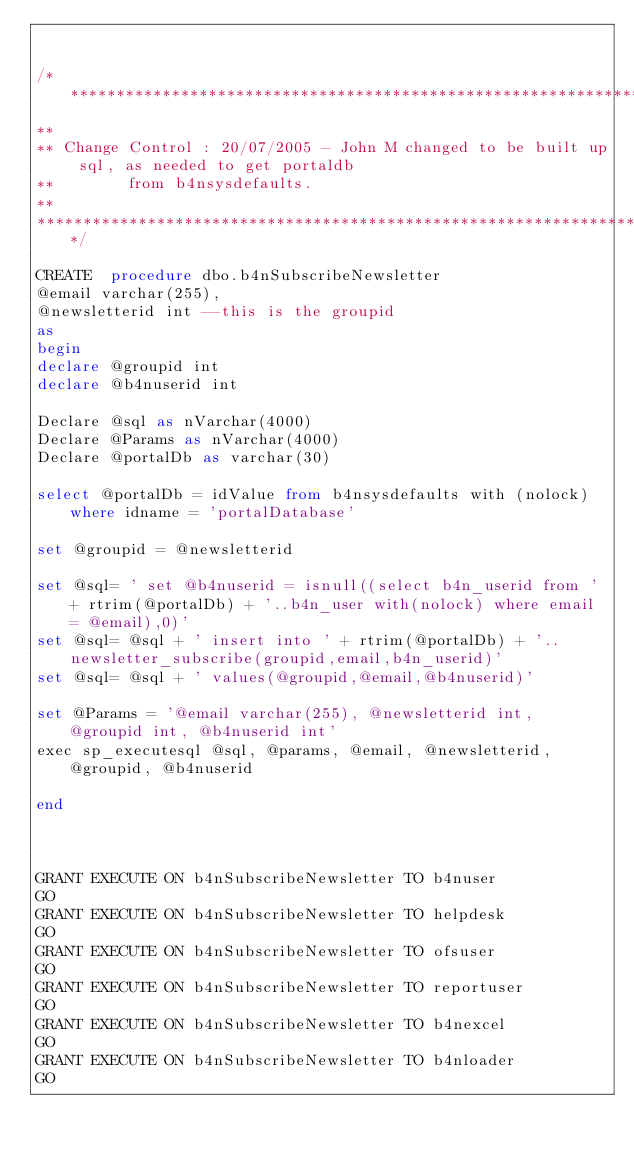<code> <loc_0><loc_0><loc_500><loc_500><_SQL_>

/**********************************************************************************************************************
**									
** Change Control	:	20/07/2005 - John M changed to be built up sql, as needed to get portaldb 
**				from b4nsysdefaults.
**
**********************************************************************************************************************/

CREATE  procedure dbo.b4nSubscribeNewsletter
@email varchar(255),
@newsletterid int --this is the groupid
as
begin
declare @groupid int
declare @b4nuserid int

Declare @sql as nVarchar(4000)
Declare @Params as nVarchar(4000)
Declare @portalDb as varchar(30)

select @portalDb = idValue from b4nsysdefaults with (nolock) where idname = 'portalDatabase'

set @groupid = @newsletterid

set @sql= ' set @b4nuserid = isnull((select b4n_userid from ' + rtrim(@portalDb) + '..b4n_user with(nolock) where email = @email),0)'
set @sql= @sql + ' insert into ' + rtrim(@portalDb) + '..newsletter_subscribe(groupid,email,b4n_userid)'
set @sql= @sql + ' values(@groupid,@email,@b4nuserid)'

set @Params = '@email varchar(255), @newsletterid int, @groupid int, @b4nuserid int'
exec sp_executesql @sql, @params, @email, @newsletterid, @groupid, @b4nuserid

end



GRANT EXECUTE ON b4nSubscribeNewsletter TO b4nuser
GO
GRANT EXECUTE ON b4nSubscribeNewsletter TO helpdesk
GO
GRANT EXECUTE ON b4nSubscribeNewsletter TO ofsuser
GO
GRANT EXECUTE ON b4nSubscribeNewsletter TO reportuser
GO
GRANT EXECUTE ON b4nSubscribeNewsletter TO b4nexcel
GO
GRANT EXECUTE ON b4nSubscribeNewsletter TO b4nloader
GO
</code> 